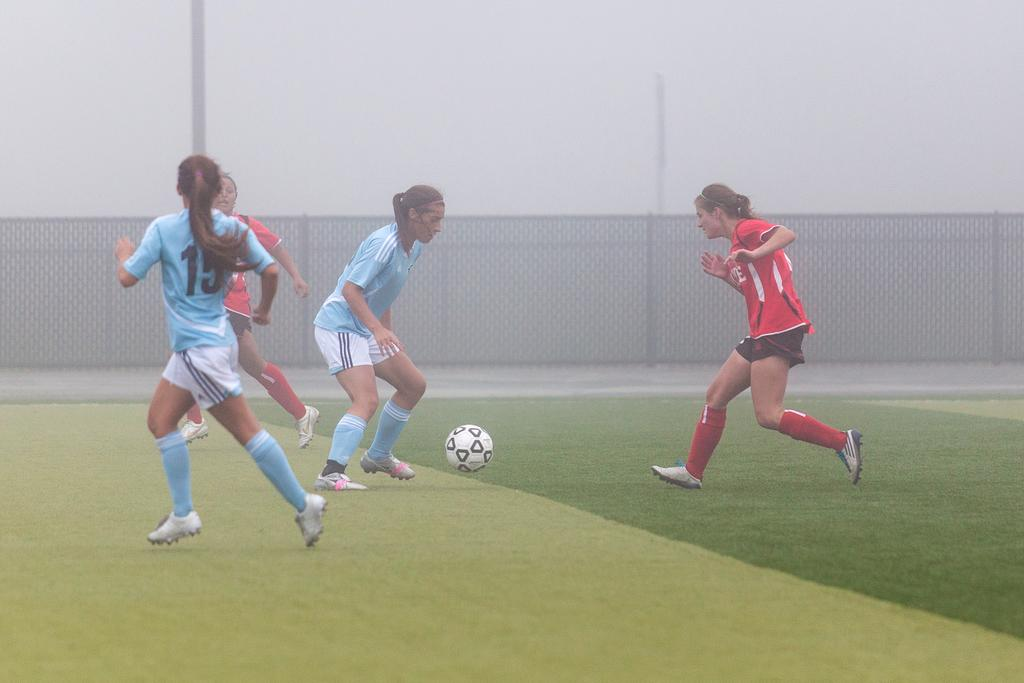<image>
Write a terse but informative summary of the picture. Two footnallers in blue, one wearing 15 are up against two others in red in the fog. 